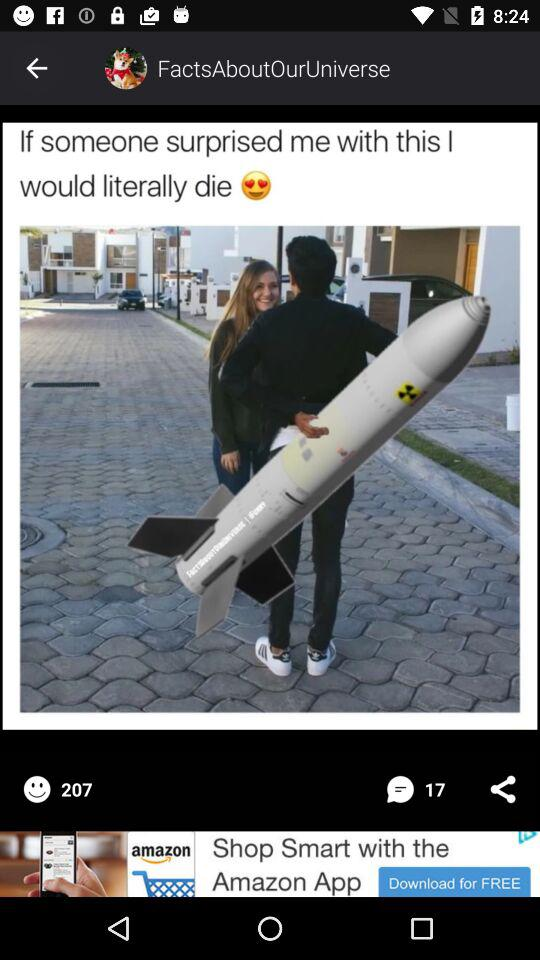How many people have reposted the meme?
When the provided information is insufficient, respond with <no answer>. <no answer> 